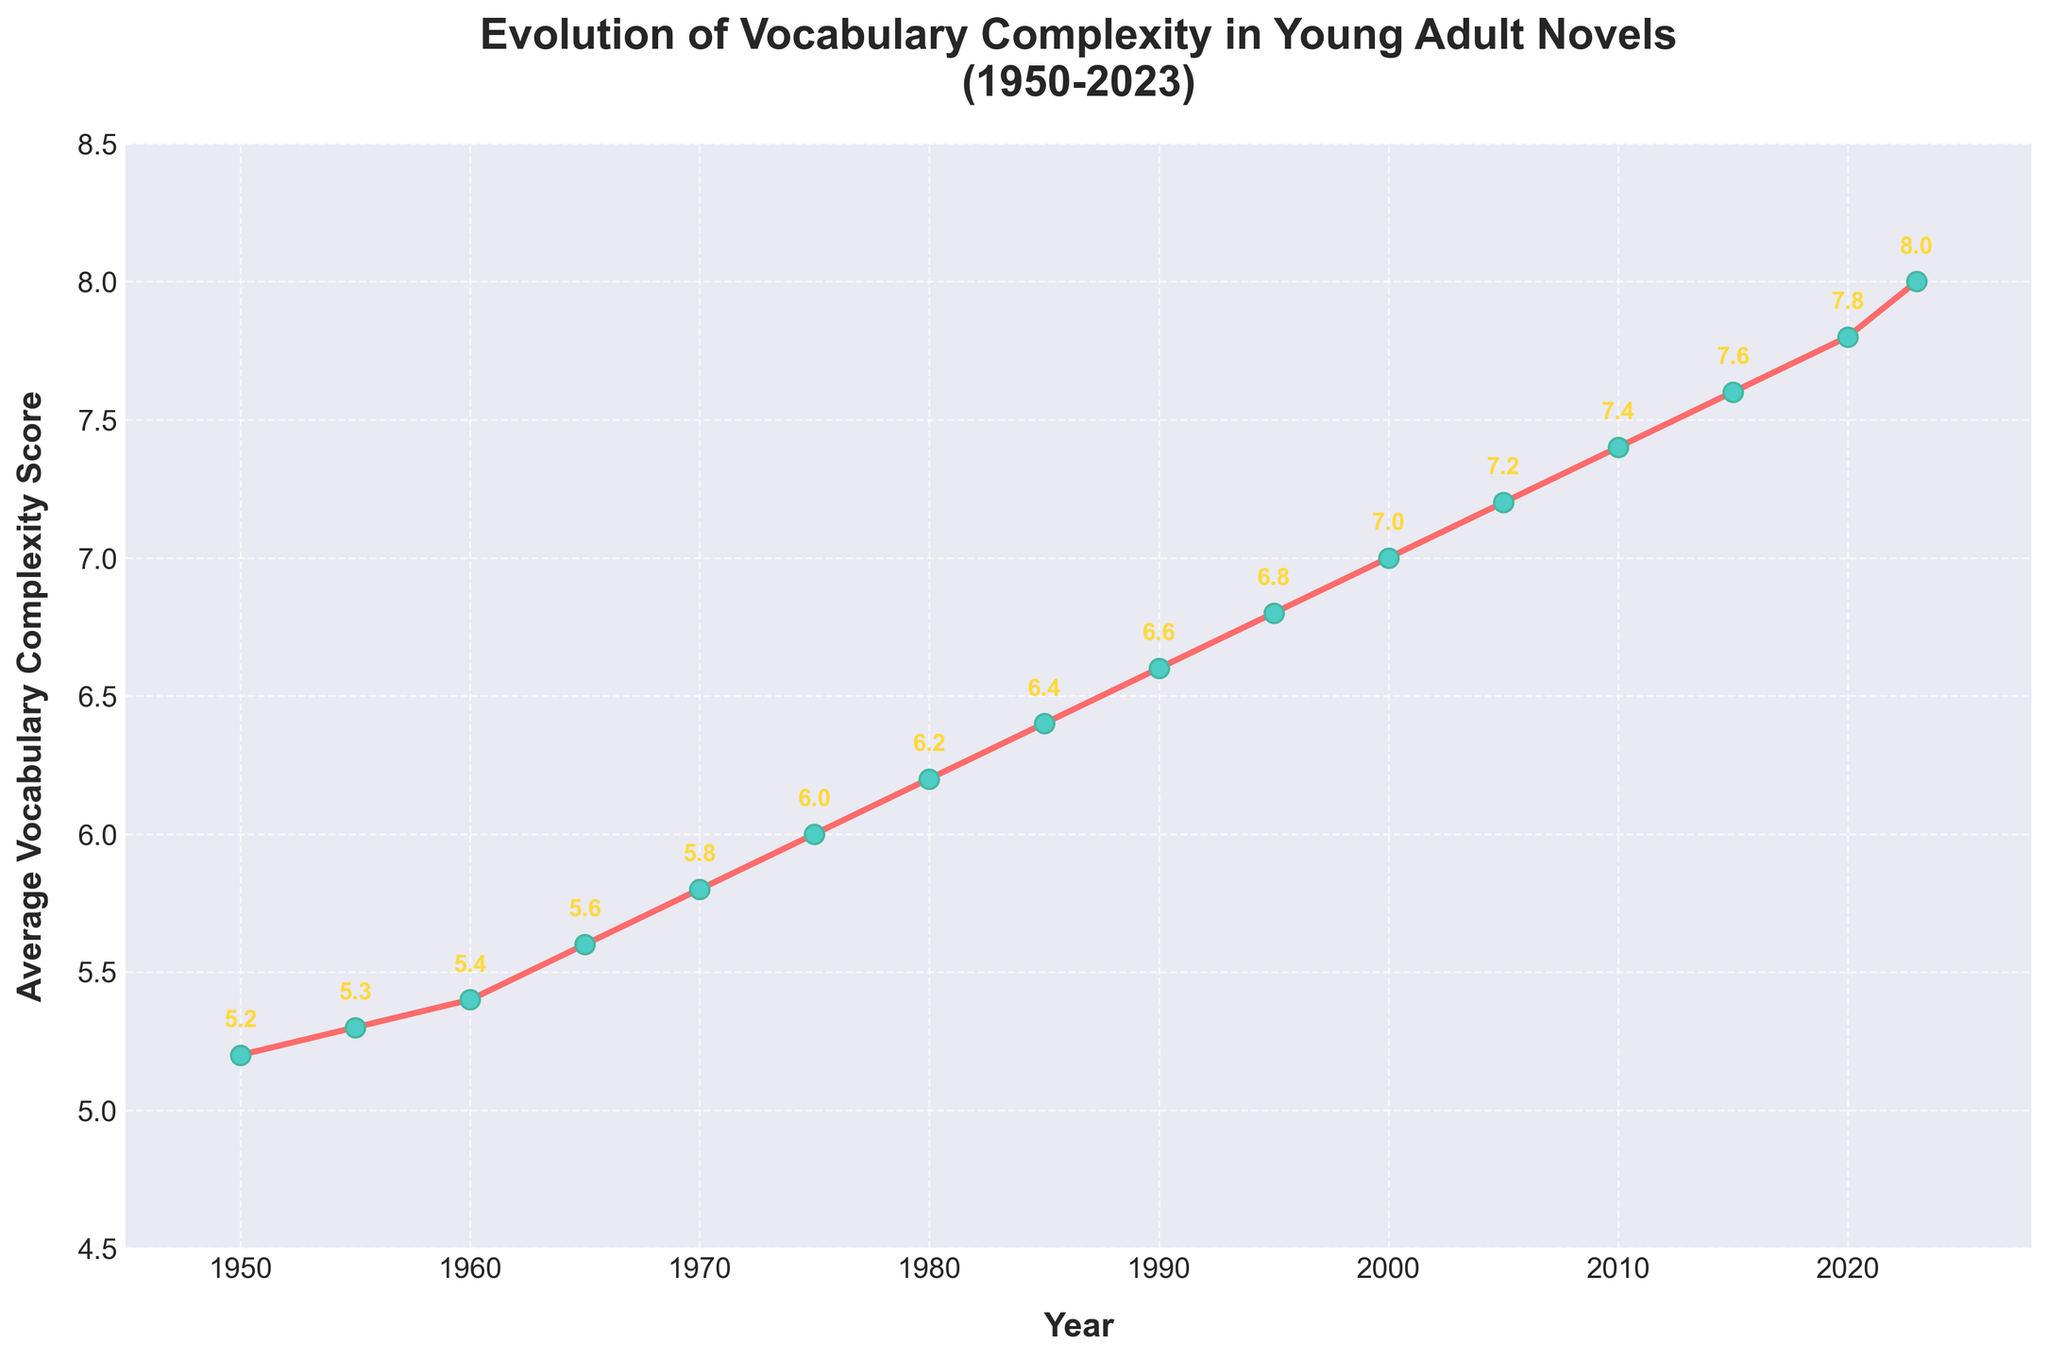What year shows the highest average vocabulary complexity score in the dataset? By looking at the line chart, we can identify the highest point on the y-axis to find the year corresponding to the highest average vocabulary complexity score. The highest point appears at the year 2023.
Answer: 2023 In which period did the average vocabulary complexity score increase the most? By observing the steepest incline in the line chart, we can determine the period with the greatest increase. The steepest incline is from 1950 to 1970.
Answer: 1950 to 1970 How much did the average vocabulary complexity score increase from 1950 to 2023? To find this, subtract the average score in 1950 from the score in 2023: 8.0 - 5.2 = 2.8
Answer: 2.8 Compare the average vocabulary complexity scores in 1965 and 2010. Which year has a higher score? By locating the points for 1965 and 2010 on the chart, we see that 2010 has a higher score (7.4) compared to 1965 (5.6).
Answer: 2010 What is the average increase in vocabulary complexity score per decade from 1950 to 2020? Calculate the total increase from 1950 (5.2) to 2020 (7.8) which is 2.6, then divide by the number of decades between 1950 and 2020 (7 decades): 2.6 / 7 ≈ 0.371
Answer: ≈ 0.371 How does the vocabulary complexity score in 1995 compare to that in 1975? Referring to the chart, the score in 1995 (6.8) is greater than in 1975 (6.0).
Answer: Greater Identify the decade with the smallest increase in average vocabulary complexity. By comparing the relatively flat sections of the line chart, the smallest increase appears between 2010 (7.4) and 2015 (7.6), with an increase of 0.2.
Answer: 2010-2015 Which decade experienced the highest rate of increase in vocabulary complexity score? To find this, observe the line chart for the steepest slope. The highest rate of increase is noted between 1950 (5.2) and 1960 (5.4), with an increase of 0.2 in one decade.
Answer: 1950-1960 What is the average vocabulary complexity score for the year range between 1980 and 2000 inclusive? Sum the scores for the years 1980, 1985, 1990, 1995, and 2000: (6.2 + 6.4 + 6.6 + 6.8 + 7.0) = 33, then divide by the number of data points (5): 33 / 5 = 6.6
Answer: 6.6 